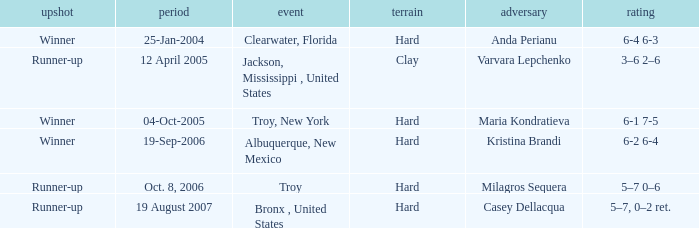What was the surface of the game that resulted in a final score of 6-1 7-5? Hard. 